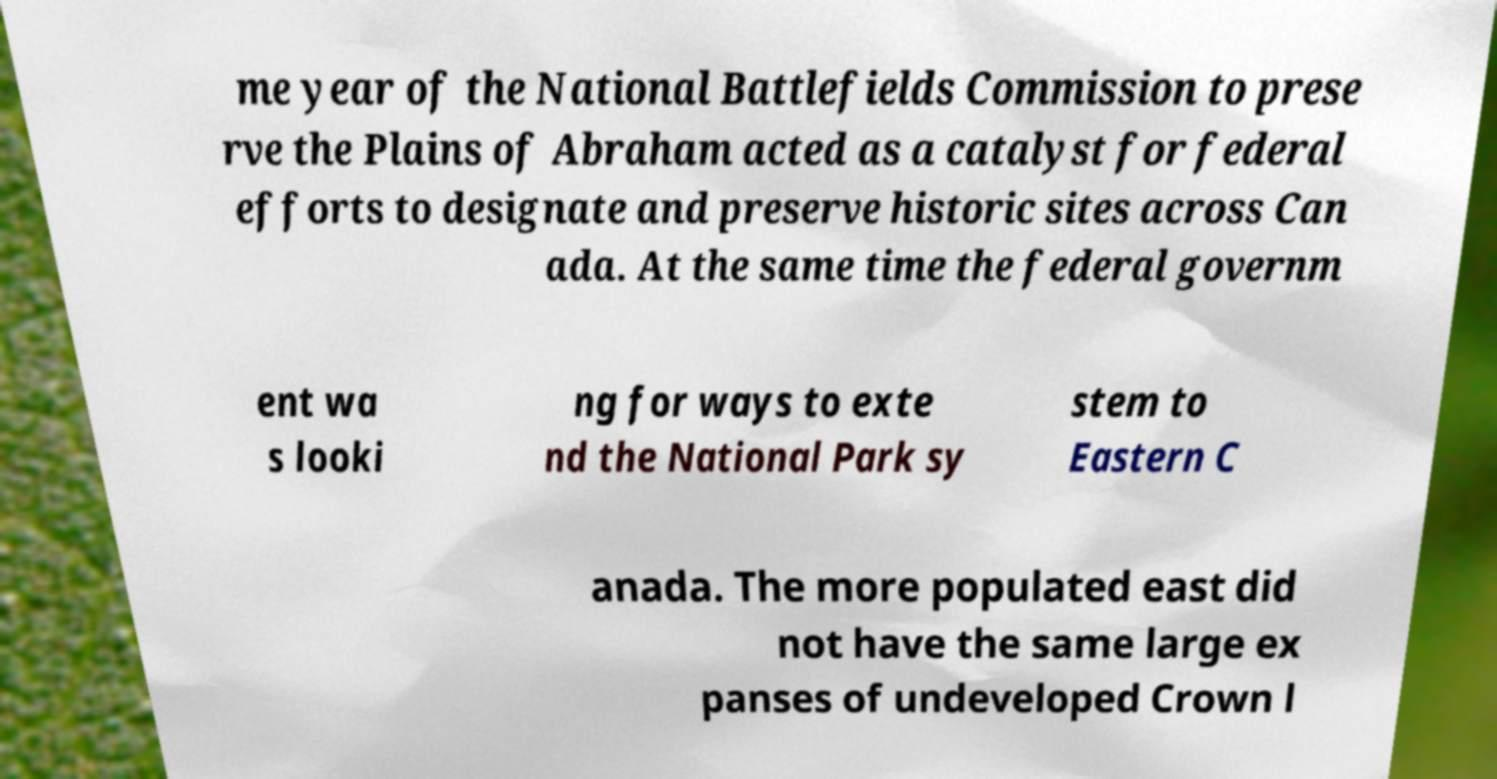Can you read and provide the text displayed in the image?This photo seems to have some interesting text. Can you extract and type it out for me? me year of the National Battlefields Commission to prese rve the Plains of Abraham acted as a catalyst for federal efforts to designate and preserve historic sites across Can ada. At the same time the federal governm ent wa s looki ng for ways to exte nd the National Park sy stem to Eastern C anada. The more populated east did not have the same large ex panses of undeveloped Crown l 